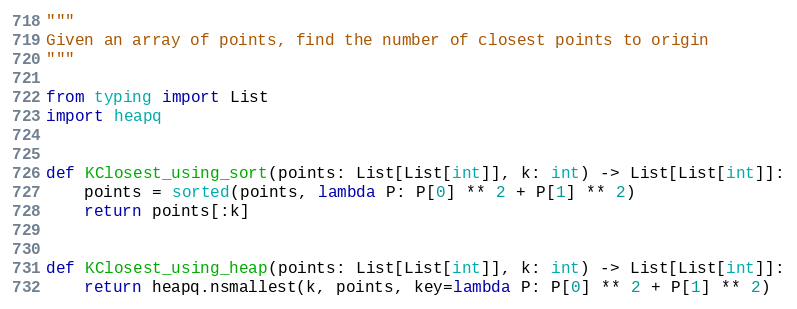Convert code to text. <code><loc_0><loc_0><loc_500><loc_500><_Python_>"""
Given an array of points, find the number of closest points to origin
"""

from typing import List
import heapq


def KClosest_using_sort(points: List[List[int]], k: int) -> List[List[int]]:
    points = sorted(points, lambda P: P[0] ** 2 + P[1] ** 2)
    return points[:k]


def KClosest_using_heap(points: List[List[int]], k: int) -> List[List[int]]:
    return heapq.nsmallest(k, points, key=lambda P: P[0] ** 2 + P[1] ** 2)
</code> 